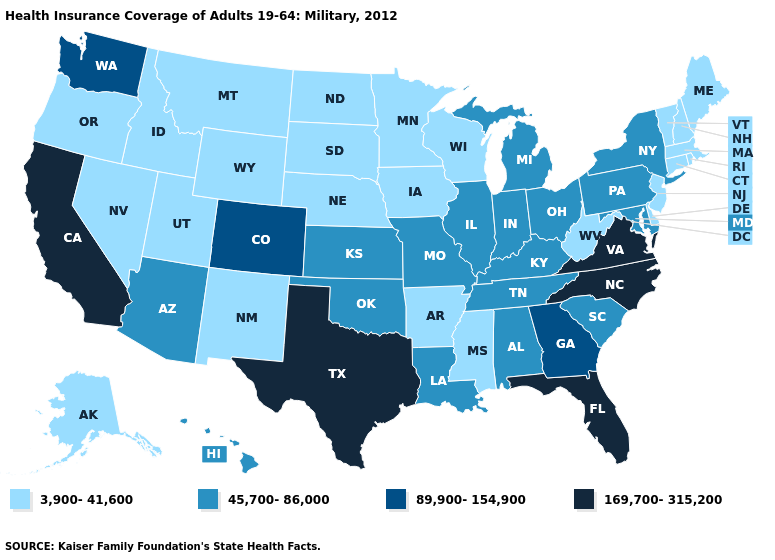How many symbols are there in the legend?
Keep it brief. 4. Does the first symbol in the legend represent the smallest category?
Keep it brief. Yes. What is the lowest value in the South?
Short answer required. 3,900-41,600. Does the map have missing data?
Quick response, please. No. Which states have the lowest value in the USA?
Answer briefly. Alaska, Arkansas, Connecticut, Delaware, Idaho, Iowa, Maine, Massachusetts, Minnesota, Mississippi, Montana, Nebraska, Nevada, New Hampshire, New Jersey, New Mexico, North Dakota, Oregon, Rhode Island, South Dakota, Utah, Vermont, West Virginia, Wisconsin, Wyoming. Name the states that have a value in the range 45,700-86,000?
Give a very brief answer. Alabama, Arizona, Hawaii, Illinois, Indiana, Kansas, Kentucky, Louisiana, Maryland, Michigan, Missouri, New York, Ohio, Oklahoma, Pennsylvania, South Carolina, Tennessee. Which states have the lowest value in the USA?
Give a very brief answer. Alaska, Arkansas, Connecticut, Delaware, Idaho, Iowa, Maine, Massachusetts, Minnesota, Mississippi, Montana, Nebraska, Nevada, New Hampshire, New Jersey, New Mexico, North Dakota, Oregon, Rhode Island, South Dakota, Utah, Vermont, West Virginia, Wisconsin, Wyoming. Does the first symbol in the legend represent the smallest category?
Answer briefly. Yes. Is the legend a continuous bar?
Keep it brief. No. Name the states that have a value in the range 169,700-315,200?
Keep it brief. California, Florida, North Carolina, Texas, Virginia. What is the value of Missouri?
Quick response, please. 45,700-86,000. How many symbols are there in the legend?
Be succinct. 4. Does California have the highest value in the West?
Short answer required. Yes. Which states hav the highest value in the South?
Answer briefly. Florida, North Carolina, Texas, Virginia. 